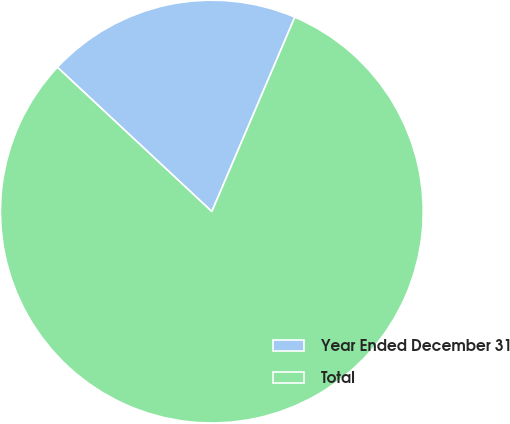Convert chart to OTSL. <chart><loc_0><loc_0><loc_500><loc_500><pie_chart><fcel>Year Ended December 31<fcel>Total<nl><fcel>19.46%<fcel>80.54%<nl></chart> 